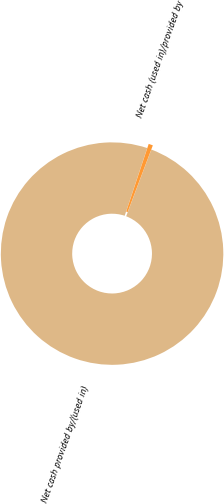<chart> <loc_0><loc_0><loc_500><loc_500><pie_chart><fcel>Net cash provided by/(used in)<fcel>Net cash (used in)/provided by<nl><fcel>99.37%<fcel>0.63%<nl></chart> 